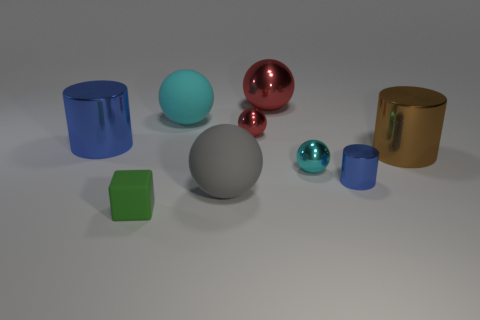What materials are visible in the objects presented in the image? The image displays objects with various materials including metallic finishes on the cylinders and the red sphere, a matte finish on the cubes, and a smooth glossy finish on the other spherical objects. 